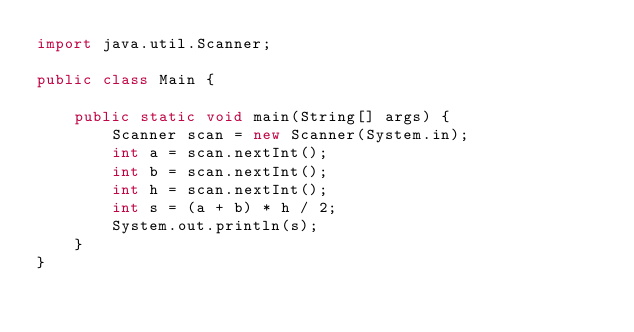Convert code to text. <code><loc_0><loc_0><loc_500><loc_500><_Java_>import java.util.Scanner;

public class Main {

	public static void main(String[] args) {
		Scanner scan = new Scanner(System.in);
		int a = scan.nextInt();
		int b = scan.nextInt();
		int h = scan.nextInt();
		int s = (a + b) * h / 2;
		System.out.println(s);
	}
}</code> 